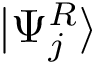Convert formula to latex. <formula><loc_0><loc_0><loc_500><loc_500>| \Psi _ { j } ^ { R } \rangle</formula> 